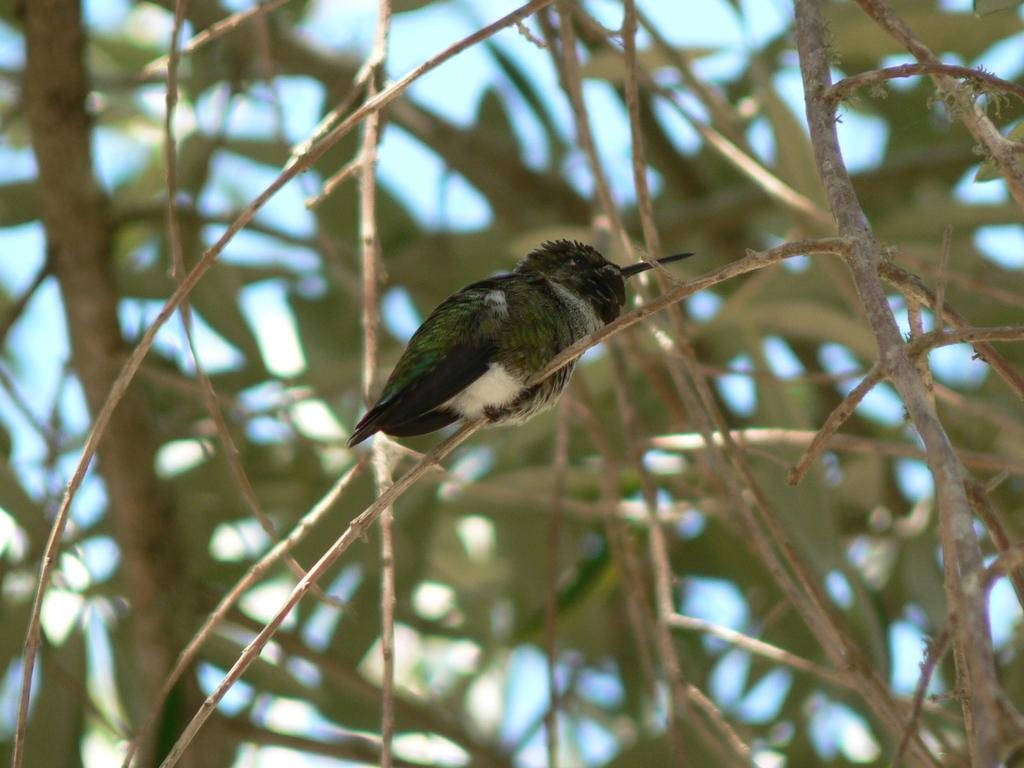What type of natural element is visible in the image? There are branches of a tree in the image. What animal can be seen in the image? There is a bird in the image. What colors are present on the bird? The bird has black, white, and green colors. How is the bird positioned in the image? The bird is blurred in the background. What is the color of the sky in the image? The sky is blue in the image. What type of badge can be seen hanging from the bird's throat in the image? There is no badge present in the image, and the bird does not have a throat. --- Facts: 1. There is a person sitting on a chair in the image. 2. The person is holding a book. 3. The book has a red cover. 4. There is a table next to the chair. 5. The table has a lamp on it. Absurd Topics: elephant, ocean, bicycle Conversation: What is the person in the image doing? The person is sitting on a chair in the image. What object is the person holding? The person is holding a book. What is the color of the book's cover? The book has a red cover. What is located next to the chair in the image? There is a table next to the chair. What item can be seen on the table? The table has a lamp on it. Reasoning: Let's think step by step in order to produce the conversation. We start by identifying the main subject in the image, which is the person sitting on a chair. Then, we expand the conversation to include the object the person is holding, which is a book. We describe the book's color and mention the presence of a table and a lamp. Each question is designed to elicit a specific detail about the image that is known from the provided facts. Absurd Question/Answer: Can you see an elephant swimming in the ocean in the image? No, there is no elephant or ocean present in the image. 